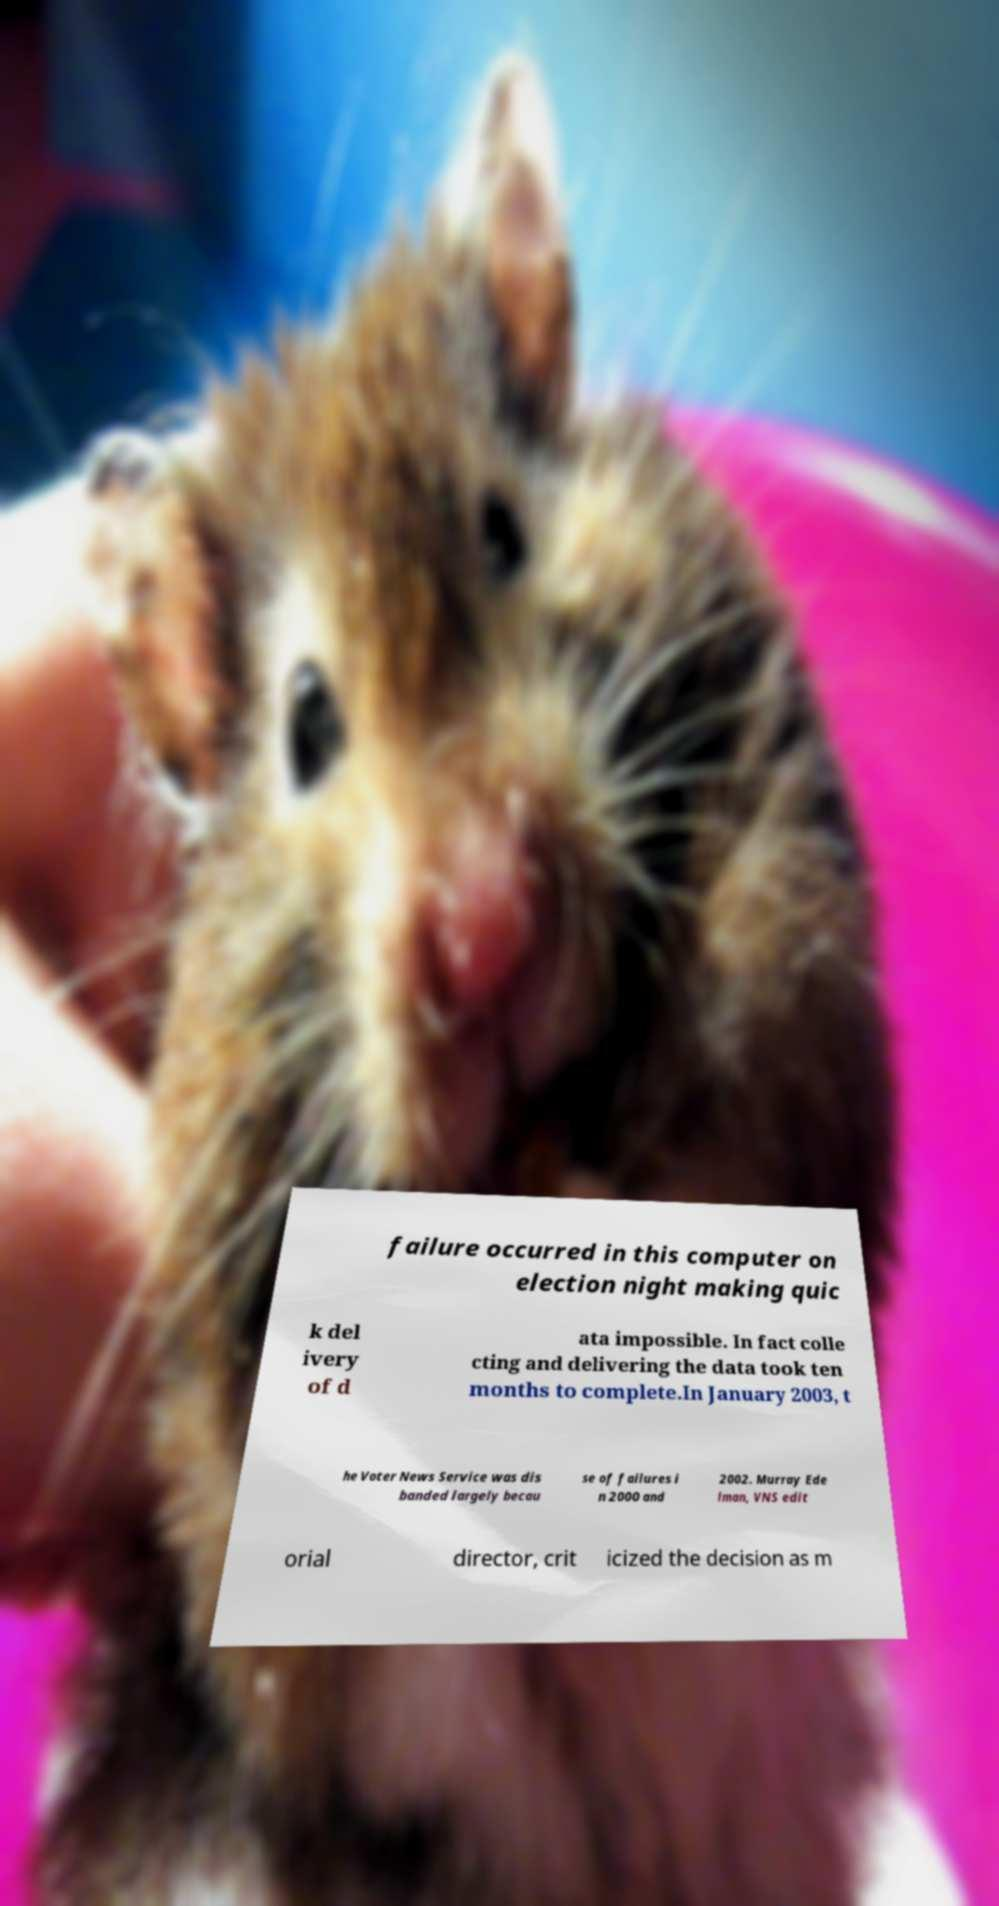What messages or text are displayed in this image? I need them in a readable, typed format. failure occurred in this computer on election night making quic k del ivery of d ata impossible. In fact colle cting and delivering the data took ten months to complete.In January 2003, t he Voter News Service was dis banded largely becau se of failures i n 2000 and 2002. Murray Ede lman, VNS edit orial director, crit icized the decision as m 